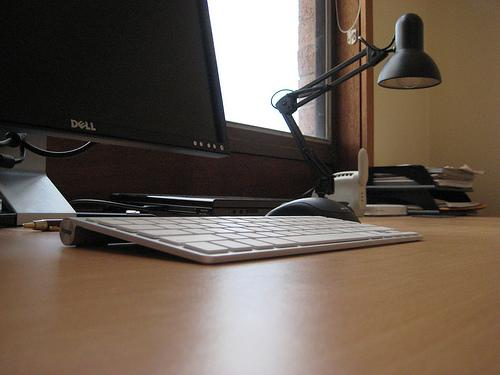What does the computer setup consist of in the image? A black Dell monitor, white keyboard, black computer mouse, and a white modem. Describe the lighting source in the image. There is a black desk lamp with a light bulb inside it. Briefly mention the most prominent objects in the image. A black desk lamp, white keyboard, black Dell computer monitor, wooden computer desk, and a window behind the desk. Describe the window appearance and its related element. There is a window behind the computer desk with a drawstring for window treatments. Mention the writing instrument visible in the image. One pen is visible on the desk near the keyboard. Enumerate the electronic devices in the image. Black Dell computer monitor, white keyboard, black computer mouse, white modem, and a laptop. Explain the type of furniture present in the image. There is a wooden computer desk in the room. Mention the organization system for papers in the image. A black paper rack helps organize stacks of papers on the desk. Identify the brand name mentioned in the image. Dell is written on the computer monitor. Describe the overall scene presented in the image. A workspace with a wooden desk containing a computer setup, a desk lamp, and various writing instruments, located near a window. 